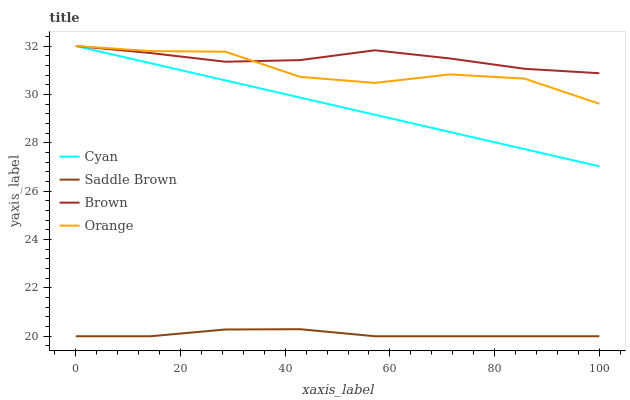Does Cyan have the minimum area under the curve?
Answer yes or no. No. Does Cyan have the maximum area under the curve?
Answer yes or no. No. Is Saddle Brown the smoothest?
Answer yes or no. No. Is Saddle Brown the roughest?
Answer yes or no. No. Does Cyan have the lowest value?
Answer yes or no. No. Does Saddle Brown have the highest value?
Answer yes or no. No. Is Saddle Brown less than Brown?
Answer yes or no. Yes. Is Cyan greater than Saddle Brown?
Answer yes or no. Yes. Does Saddle Brown intersect Brown?
Answer yes or no. No. 